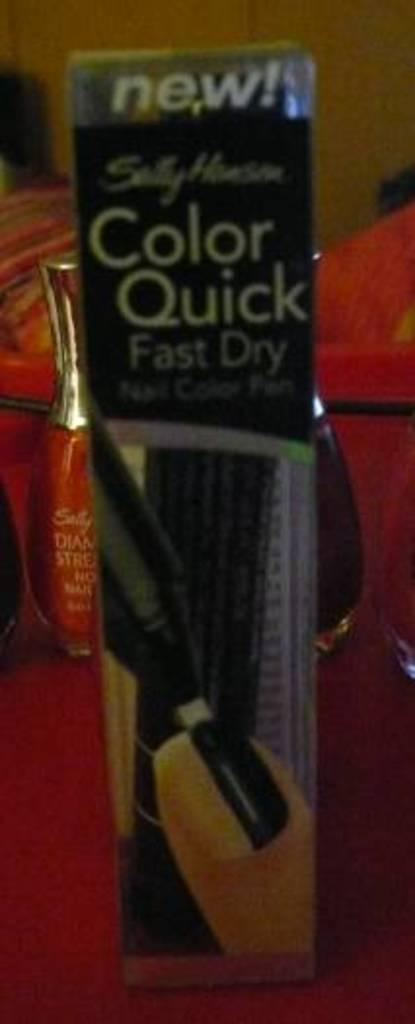<image>
Render a clear and concise summary of the photo. Sally Hanson Color Quick fast drying nail color pen in black. 